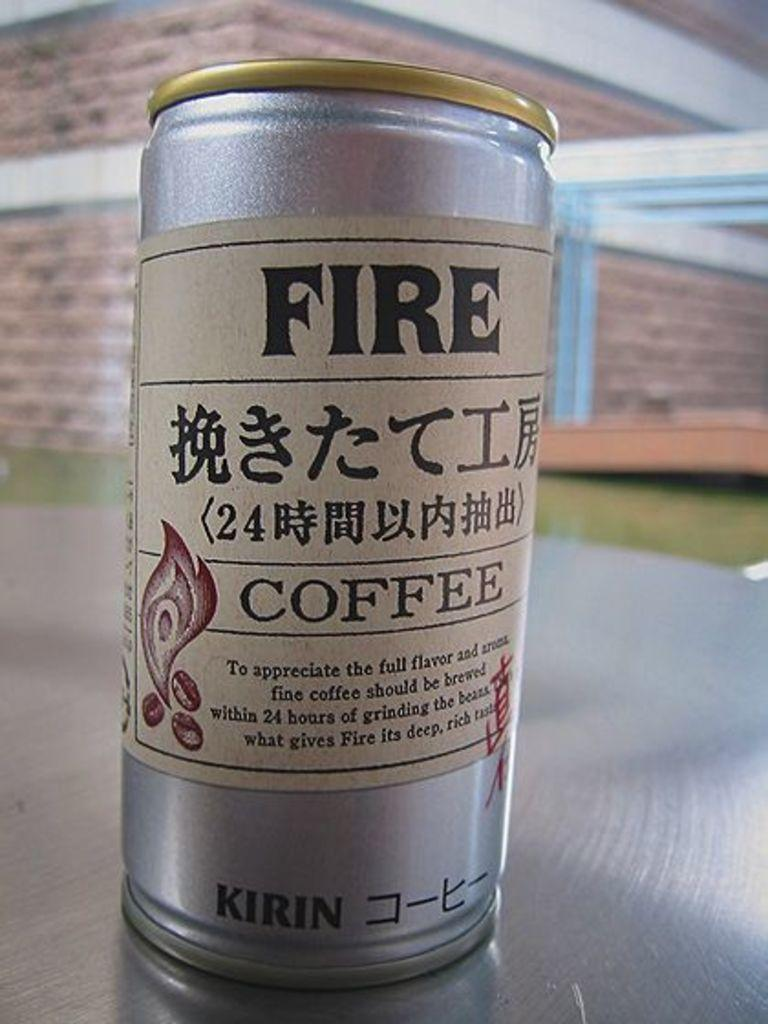<image>
Create a compact narrative representing the image presented. a can that has the word fire on it 